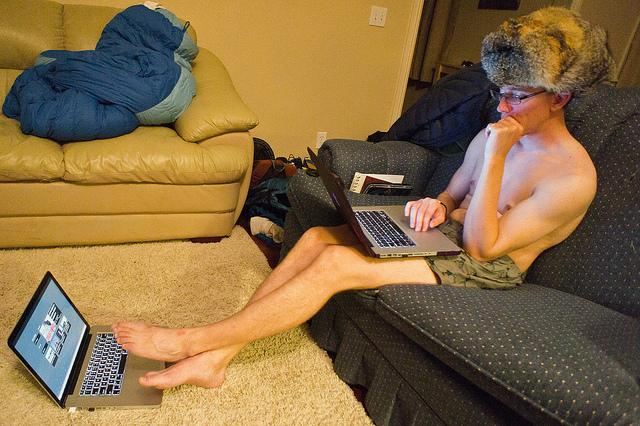What area of the computer is he touching with his fingers?

Choices:
A) trackpad
B) screen
C) keyboard
D) usb slot trackpad 